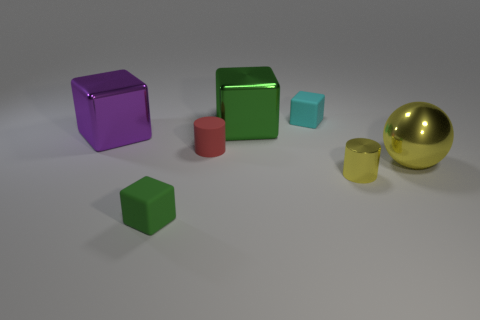Subtract 1 blocks. How many blocks are left? 3 Subtract all gray cubes. Subtract all gray cylinders. How many cubes are left? 4 Add 2 big purple metal objects. How many objects exist? 9 Subtract all blocks. How many objects are left? 3 Subtract all big red cylinders. Subtract all yellow metal things. How many objects are left? 5 Add 3 purple blocks. How many purple blocks are left? 4 Add 5 red matte things. How many red matte things exist? 6 Subtract 0 blue cylinders. How many objects are left? 7 